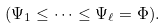<formula> <loc_0><loc_0><loc_500><loc_500>( \Psi _ { 1 } \leq \cdots \leq \Psi _ { \ell } = \Phi ) .</formula> 